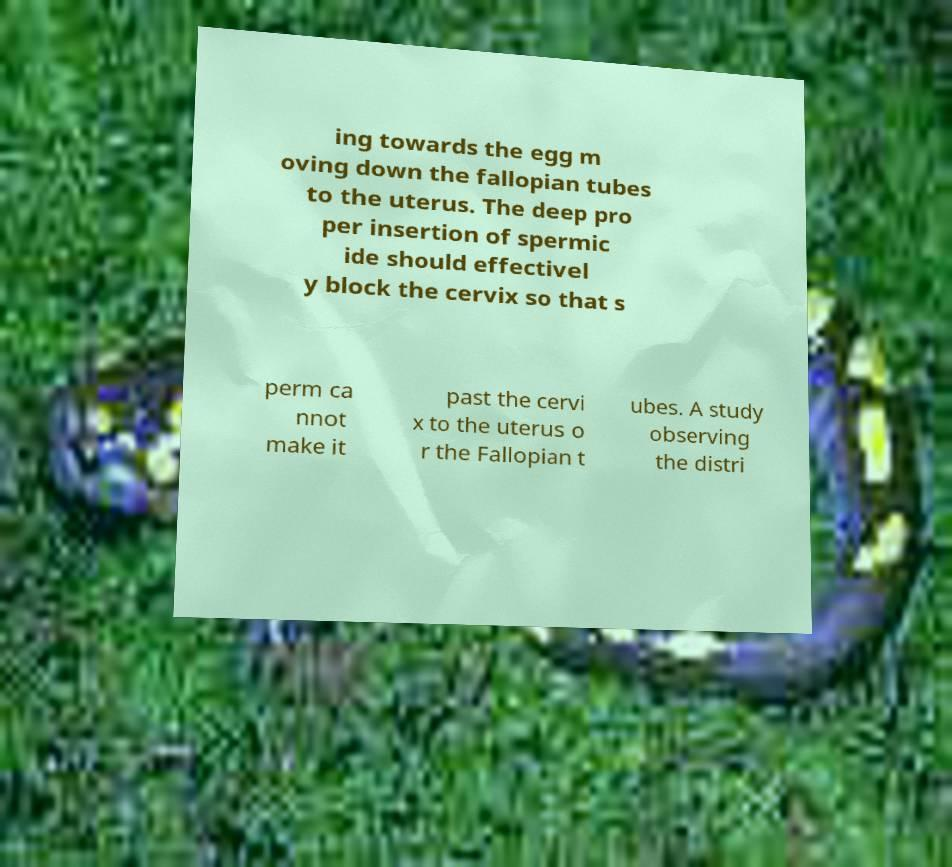Can you read and provide the text displayed in the image?This photo seems to have some interesting text. Can you extract and type it out for me? ing towards the egg m oving down the fallopian tubes to the uterus. The deep pro per insertion of spermic ide should effectivel y block the cervix so that s perm ca nnot make it past the cervi x to the uterus o r the Fallopian t ubes. A study observing the distri 